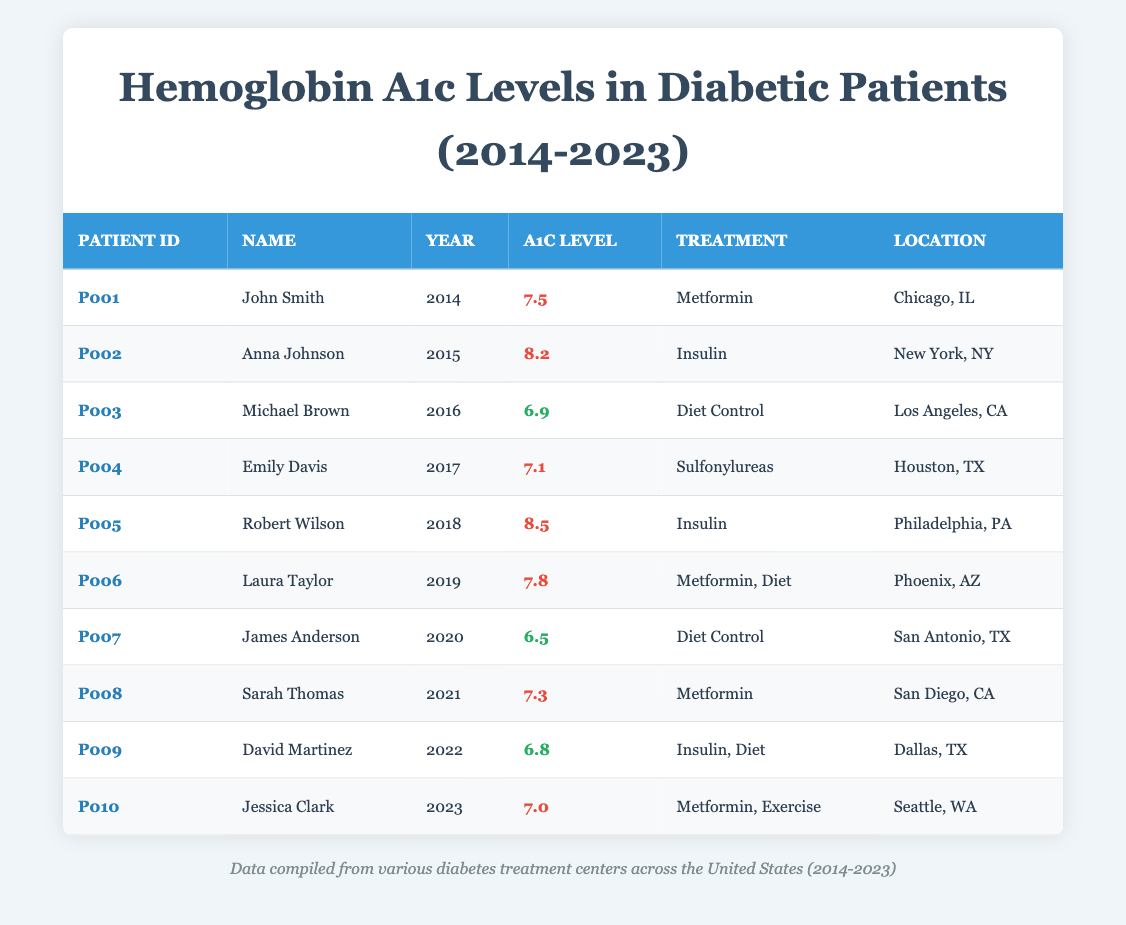What was the highest recorded A1c level in the table? The table shows A1c levels for various patients over the years. The highest level appears in the entry for Robert Wilson in 2018, where the A1c level is 8.5.
Answer: 8.5 Which patient had the lowest A1c level and in which year? The patient with the lowest A1c level is James Anderson, recorded in the year 2020, with an A1c level of 6.5.
Answer: James Anderson, 2020 How many patients had an A1c level above 7 in the year 2018? In 2018, we have Robert Wilson with an A1c level of 8.5, which is above 7. There is only one patient in that year with a level above the threshold.
Answer: 1 Is there a patient named Sarah Thomas in the data? Yes, Sarah Thomas appears in the table with an A1c level of 7.3 in the year 2021.
Answer: Yes What is the average A1c level of patients from 2014 to 2023? To find the average, we need to sum the A1c levels (7.5 + 8.2 + 6.9 + 7.1 + 8.5 + 7.8 + 6.5 + 7.3 + 6.8 + 7.0) and then divide by 10 (the number of patients). The total is 78.8; dividing by 10 gives an average of 7.88.
Answer: 7.88 How many years had at least one patient with an A1c level below 7? We need to check each year for patients with levels under 7. Years 2016, 2020, and 2022 all have patients below 7 (Michael Brown, James Anderson, and David Martinez). Thus, 3 years have patients with levels under 7.
Answer: 3 What was the treatment type for David Martinez in 2022? Referring to the entry for David Martinez in 2022, his treatment was recorded as "Insulin, Diet."
Answer: Insulin, Diet Which two treatment types were used by patients with A1c levels above 7 in 2021? Looking at the data for 2021, Sarah Thomas had a level of 7.3 and was treated with Metformin. From previous years, Anna Johnson (2015, Insulin), and several others also had treatments associated with levels above 7. The two treatments that stand out are "Insulin" and "Metformin."
Answer: Insulin, Metformin 